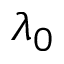<formula> <loc_0><loc_0><loc_500><loc_500>\lambda _ { 0 }</formula> 